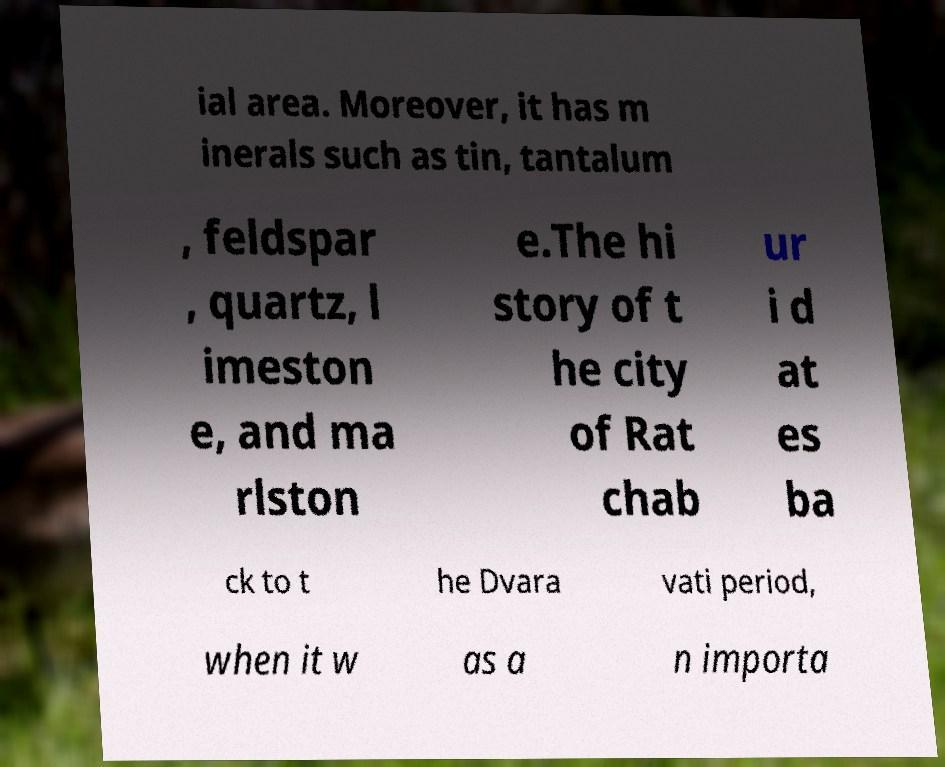Can you read and provide the text displayed in the image?This photo seems to have some interesting text. Can you extract and type it out for me? ial area. Moreover, it has m inerals such as tin, tantalum , feldspar , quartz, l imeston e, and ma rlston e.The hi story of t he city of Rat chab ur i d at es ba ck to t he Dvara vati period, when it w as a n importa 